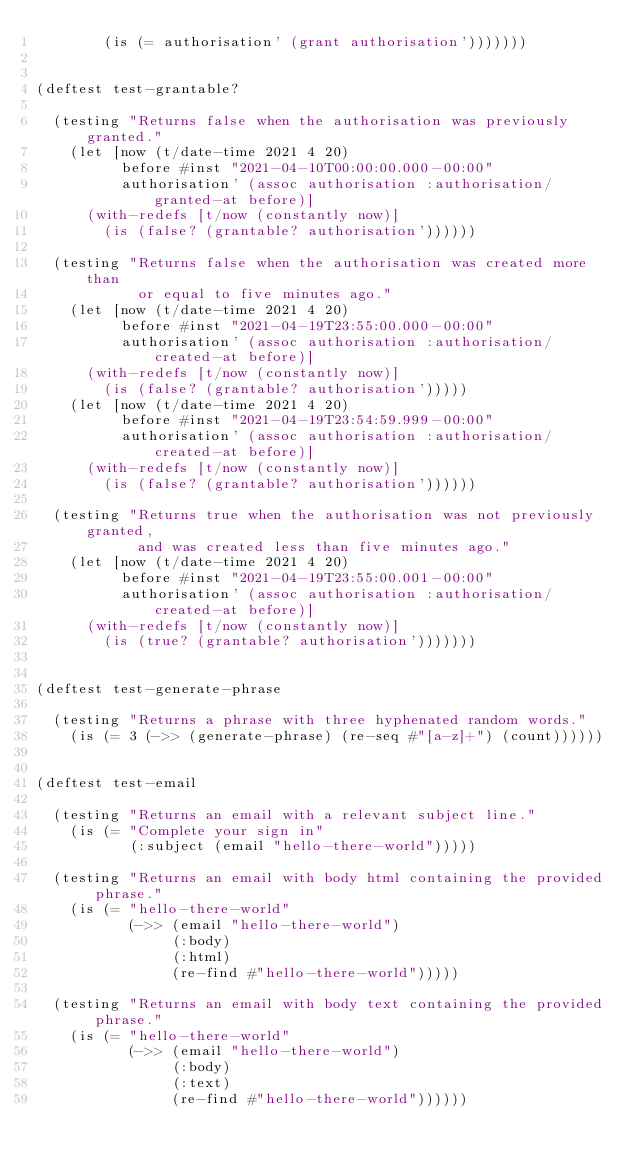<code> <loc_0><loc_0><loc_500><loc_500><_Clojure_>        (is (= authorisation' (grant authorisation')))))))


(deftest test-grantable?

  (testing "Returns false when the authorisation was previously granted."
    (let [now (t/date-time 2021 4 20)
          before #inst "2021-04-10T00:00:00.000-00:00"
          authorisation' (assoc authorisation :authorisation/granted-at before)]
      (with-redefs [t/now (constantly now)]
        (is (false? (grantable? authorisation'))))))

  (testing "Returns false when the authorisation was created more than
            or equal to five minutes ago."
    (let [now (t/date-time 2021 4 20)
          before #inst "2021-04-19T23:55:00.000-00:00"
          authorisation' (assoc authorisation :authorisation/created-at before)]
      (with-redefs [t/now (constantly now)]
        (is (false? (grantable? authorisation')))))
    (let [now (t/date-time 2021 4 20)
          before #inst "2021-04-19T23:54:59.999-00:00"
          authorisation' (assoc authorisation :authorisation/created-at before)]
      (with-redefs [t/now (constantly now)]
        (is (false? (grantable? authorisation'))))))

  (testing "Returns true when the authorisation was not previously granted,
            and was created less than five minutes ago."
    (let [now (t/date-time 2021 4 20)
          before #inst "2021-04-19T23:55:00.001-00:00"
          authorisation' (assoc authorisation :authorisation/created-at before)]
      (with-redefs [t/now (constantly now)]
        (is (true? (grantable? authorisation')))))))


(deftest test-generate-phrase

  (testing "Returns a phrase with three hyphenated random words."
    (is (= 3 (->> (generate-phrase) (re-seq #"[a-z]+") (count))))))


(deftest test-email

  (testing "Returns an email with a relevant subject line."
    (is (= "Complete your sign in"
           (:subject (email "hello-there-world")))))

  (testing "Returns an email with body html containing the provided phrase."
    (is (= "hello-there-world"
           (->> (email "hello-there-world")
                (:body)
                (:html)
                (re-find #"hello-there-world")))))

  (testing "Returns an email with body text containing the provided phrase."
    (is (= "hello-there-world"
           (->> (email "hello-there-world")
                (:body)
                (:text)
                (re-find #"hello-there-world"))))))
</code> 